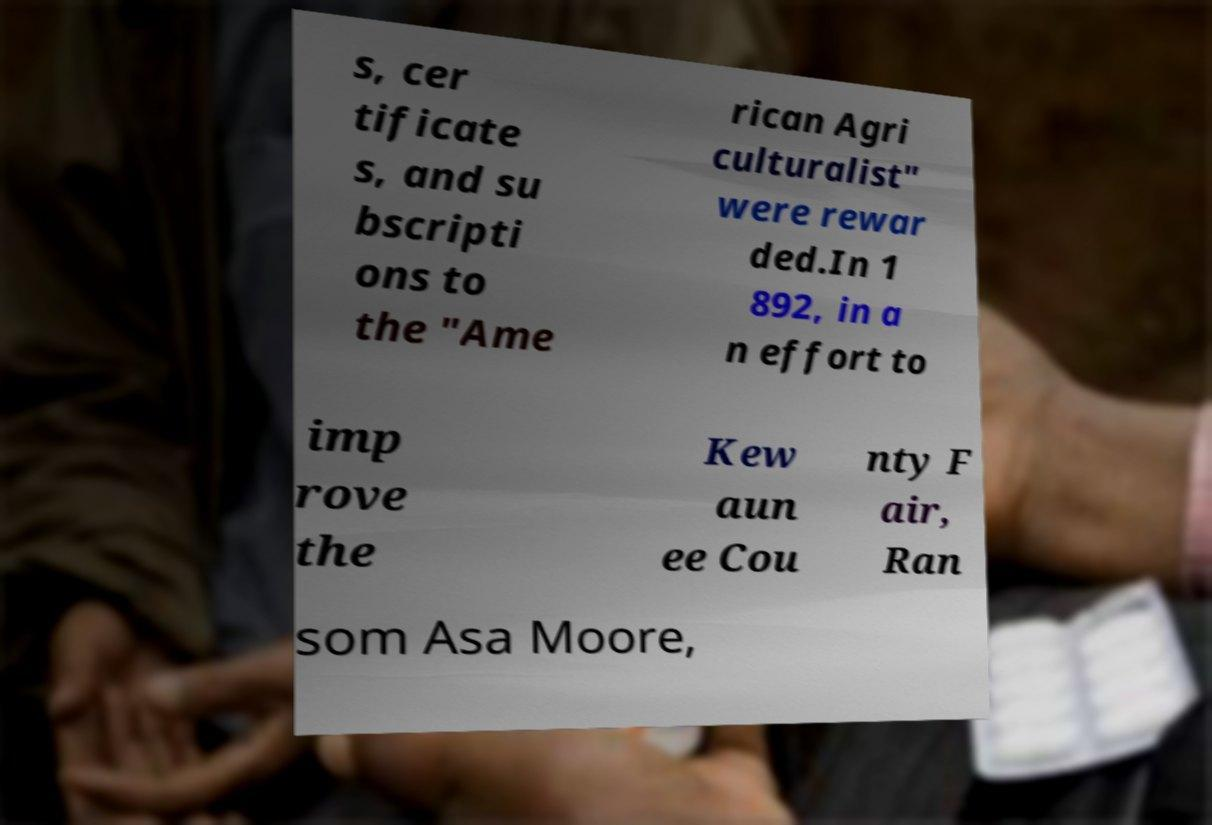Can you accurately transcribe the text from the provided image for me? s, cer tificate s, and su bscripti ons to the "Ame rican Agri culturalist" were rewar ded.In 1 892, in a n effort to imp rove the Kew aun ee Cou nty F air, Ran som Asa Moore, 